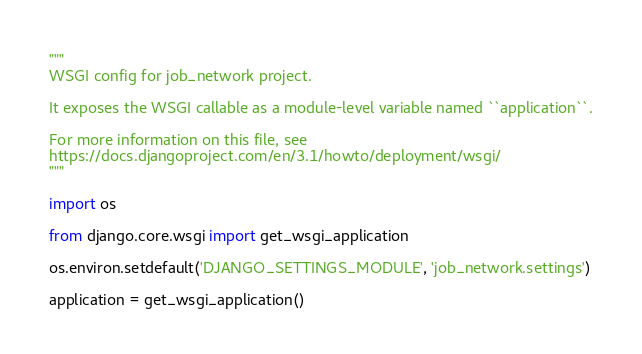<code> <loc_0><loc_0><loc_500><loc_500><_Python_>"""
WSGI config for job_network project.

It exposes the WSGI callable as a module-level variable named ``application``.

For more information on this file, see
https://docs.djangoproject.com/en/3.1/howto/deployment/wsgi/
"""

import os

from django.core.wsgi import get_wsgi_application

os.environ.setdefault('DJANGO_SETTINGS_MODULE', 'job_network.settings')

application = get_wsgi_application()
</code> 